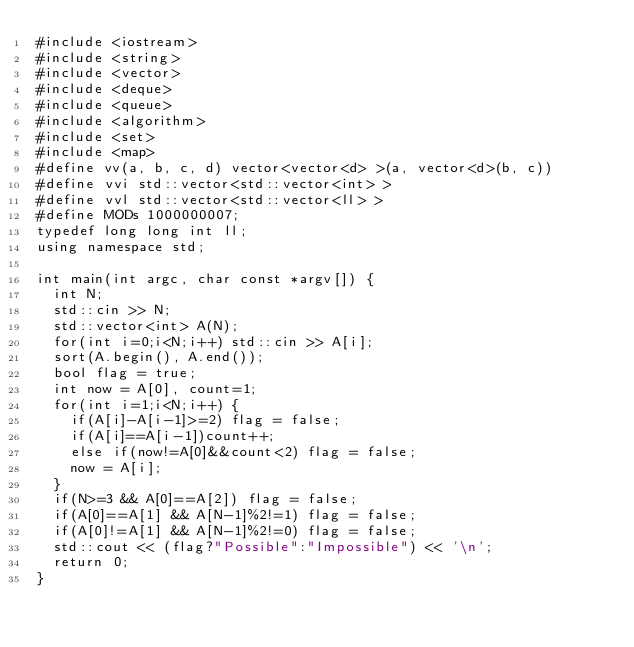<code> <loc_0><loc_0><loc_500><loc_500><_C++_>#include <iostream>
#include <string>
#include <vector>
#include <deque>
#include <queue>
#include <algorithm>
#include <set>
#include <map>
#define vv(a, b, c, d) vector<vector<d> >(a, vector<d>(b, c))
#define vvi std::vector<std::vector<int> >
#define vvl std::vector<std::vector<ll> >
#define MODs 1000000007;
typedef long long int ll;
using namespace std;

int main(int argc, char const *argv[]) {
  int N;
  std::cin >> N;
  std::vector<int> A(N);
  for(int i=0;i<N;i++) std::cin >> A[i];
  sort(A.begin(), A.end());
  bool flag = true;
  int now = A[0], count=1;
  for(int i=1;i<N;i++) {
    if(A[i]-A[i-1]>=2) flag = false;
    if(A[i]==A[i-1])count++;
    else if(now!=A[0]&&count<2) flag = false;
    now = A[i];
  }
  if(N>=3 && A[0]==A[2]) flag = false;
  if(A[0]==A[1] && A[N-1]%2!=1) flag = false;
  if(A[0]!=A[1] && A[N-1]%2!=0) flag = false;
  std::cout << (flag?"Possible":"Impossible") << '\n';
  return 0;
}
</code> 